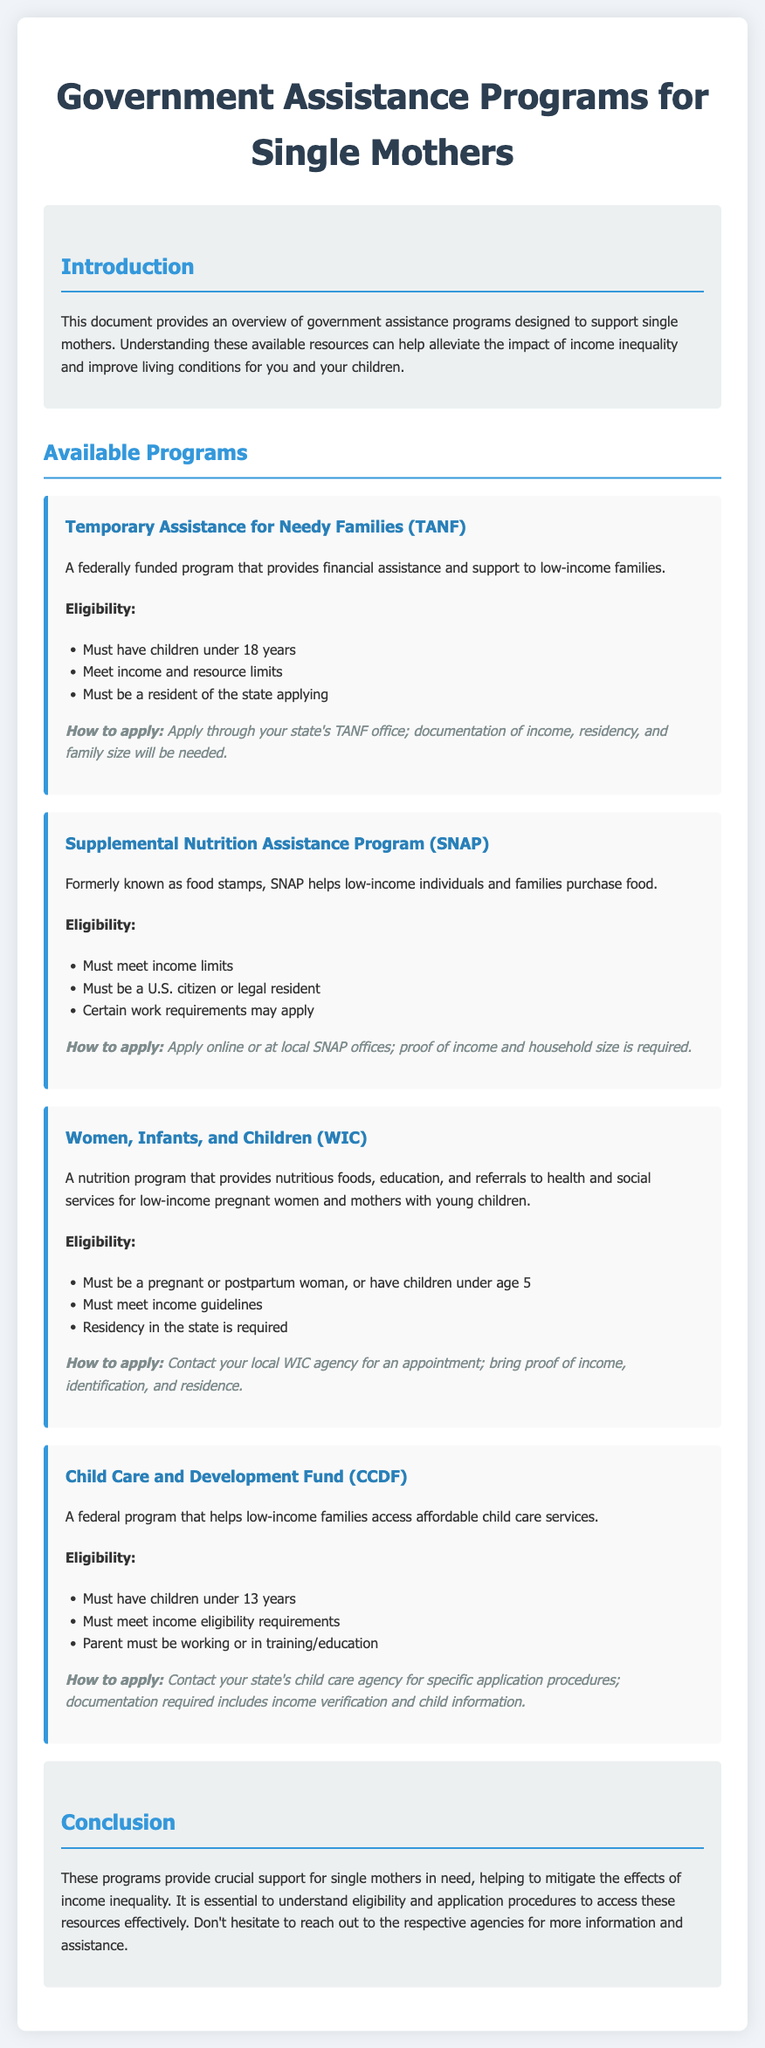What is the full name of TANF? TANF stands for Temporary Assistance for Needy Families, which is mentioned in the document as a federal program.
Answer: Temporary Assistance for Needy Families What is the age limit for children to be eligible for TANF? The eligibility section for TANF states that children must be under 18 years of age.
Answer: Under 18 years What documentation is required to apply for SNAP? The document lists proof of income and household size as required documentation for SNAP applications.
Answer: Proof of income and household size What is WIC designed to assist with? The document specifically states that WIC provides nutritious foods, education, and referrals to health and social services.
Answer: Nutritious foods, education, and referrals How old must children be to qualify for CCDF? The eligibility criteria for CCDF indicates that children must be under 13 years of age to qualify for assistance.
Answer: Under 13 years What does SNAP help families purchase? The document describes SNAP as helping low-income individuals and families to purchase food.
Answer: Food Which program assists with affordable child care services? The document states that the Child Care and Development Fund (CCDF) helps low-income families access affordable child care services.
Answer: Child Care and Development Fund (CCDF) What is the first step to apply for WIC? According to the document, the first step to apply for WIC is to contact your local WIC agency for an appointment.
Answer: Contact local WIC agency What is a requirement of all assistance programs mentioned? The document mentions that all programs have specific eligibility and application requirements that must be met.
Answer: Eligibility and application requirements 